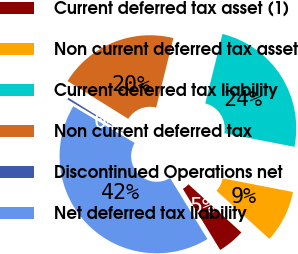Convert chart to OTSL. <chart><loc_0><loc_0><loc_500><loc_500><pie_chart><fcel>Current deferred tax asset (1)<fcel>Non current deferred tax asset<fcel>Current deferred tax liability<fcel>Non current deferred tax<fcel>Discontinued Operations net<fcel>Net deferred tax liability<nl><fcel>4.51%<fcel>8.71%<fcel>24.19%<fcel>19.99%<fcel>0.31%<fcel>42.3%<nl></chart> 